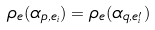<formula> <loc_0><loc_0><loc_500><loc_500>\rho _ { e } ( \alpha _ { p , e _ { i } } ) = \rho _ { e } ( \alpha _ { q , e ^ { \prime } _ { i } } )</formula> 